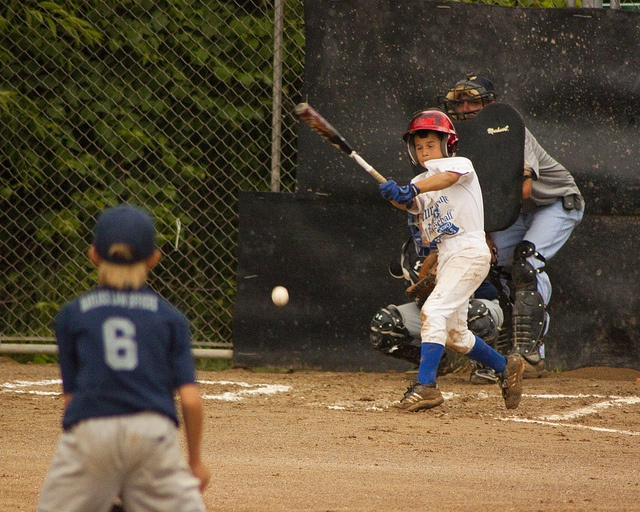Describe the objects in this image and their specific colors. I can see people in darkgreen, black, darkgray, and tan tones, people in darkgreen, lightgray, black, and tan tones, people in darkgreen, black, gray, and darkgray tones, people in darkgreen, black, gray, and darkgray tones, and people in darkgreen, black, and tan tones in this image. 